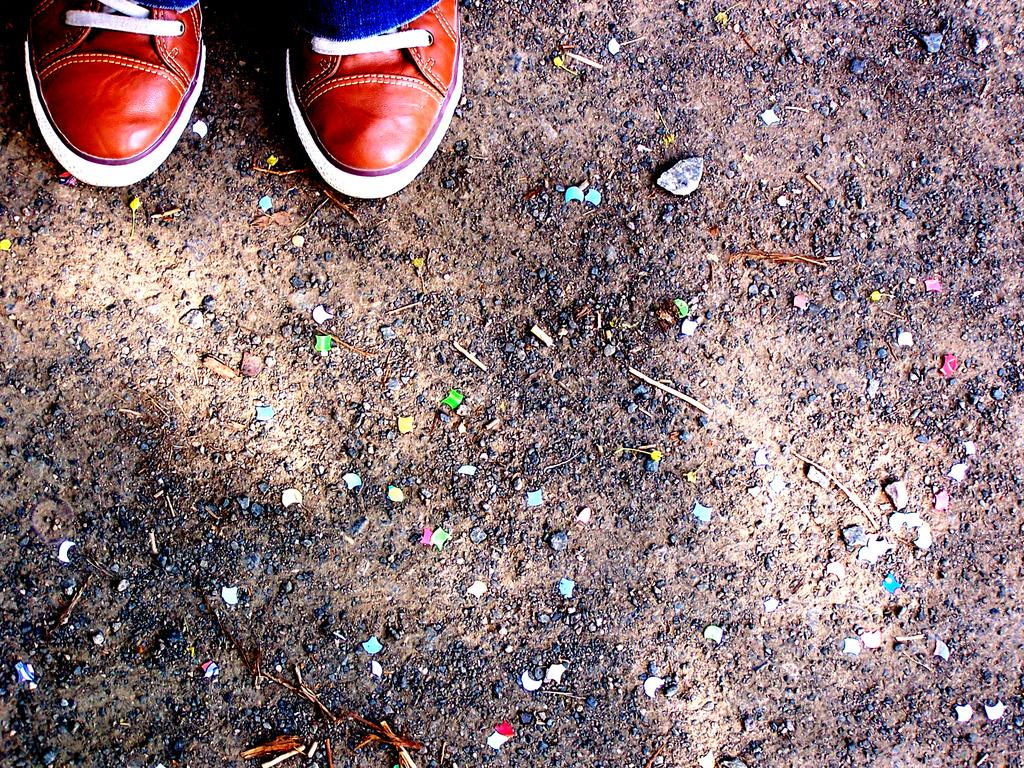What type of footwear is visible in the image? There is a pair of shoes in the image. What can be seen on the ground in the image? There are small stones on the ground in the image. What is the interest rate of the loan mentioned in the image? There is no mention of a loan or interest rate in the image; it only features a pair of shoes and small stones on the ground. 